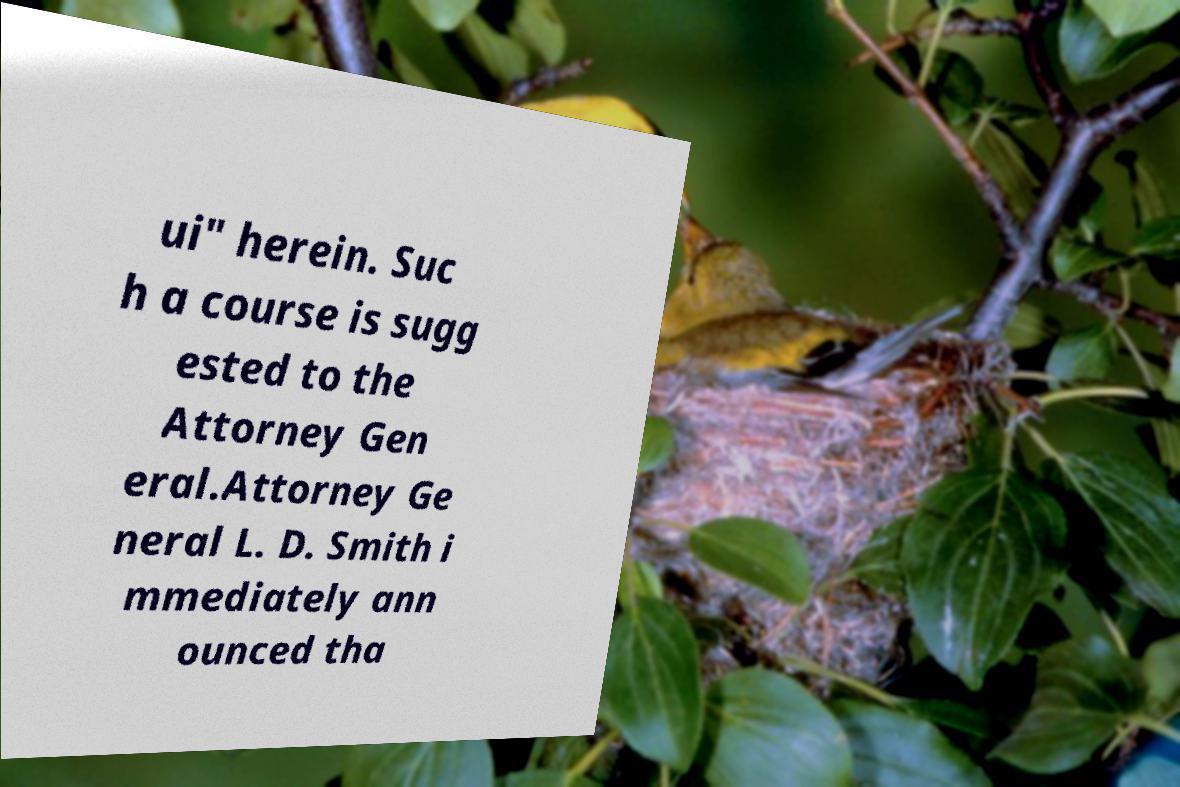Could you assist in decoding the text presented in this image and type it out clearly? ui" herein. Suc h a course is sugg ested to the Attorney Gen eral.Attorney Ge neral L. D. Smith i mmediately ann ounced tha 